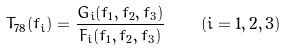<formula> <loc_0><loc_0><loc_500><loc_500>T _ { 7 8 } ( f _ { i } ) = \frac { G _ { i } ( f _ { 1 } , f _ { 2 } , f _ { 3 } ) } { F _ { i } ( f _ { 1 } , f _ { 2 } , f _ { 3 } ) } \quad ( i = 1 , 2 , 3 )</formula> 